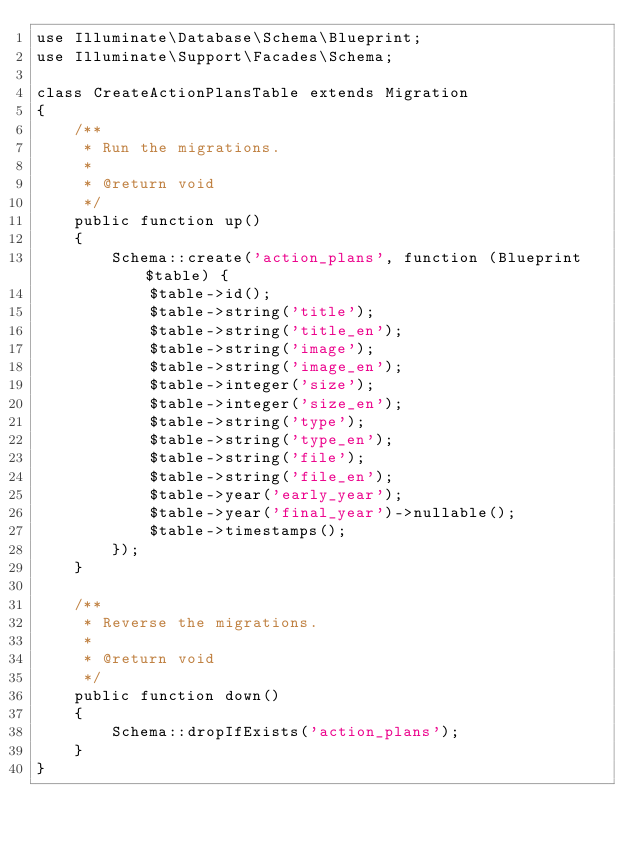Convert code to text. <code><loc_0><loc_0><loc_500><loc_500><_PHP_>use Illuminate\Database\Schema\Blueprint;
use Illuminate\Support\Facades\Schema;

class CreateActionPlansTable extends Migration
{
    /**
     * Run the migrations.
     *
     * @return void
     */
    public function up()
    {
        Schema::create('action_plans', function (Blueprint $table) {
            $table->id();
            $table->string('title');
            $table->string('title_en');
            $table->string('image');
            $table->string('image_en');
            $table->integer('size');
            $table->integer('size_en');
            $table->string('type');
            $table->string('type_en');
            $table->string('file');
            $table->string('file_en');
            $table->year('early_year');
            $table->year('final_year')->nullable();
            $table->timestamps();
        });
    }

    /**
     * Reverse the migrations.
     *
     * @return void
     */
    public function down()
    {
        Schema::dropIfExists('action_plans');
    }
}
</code> 